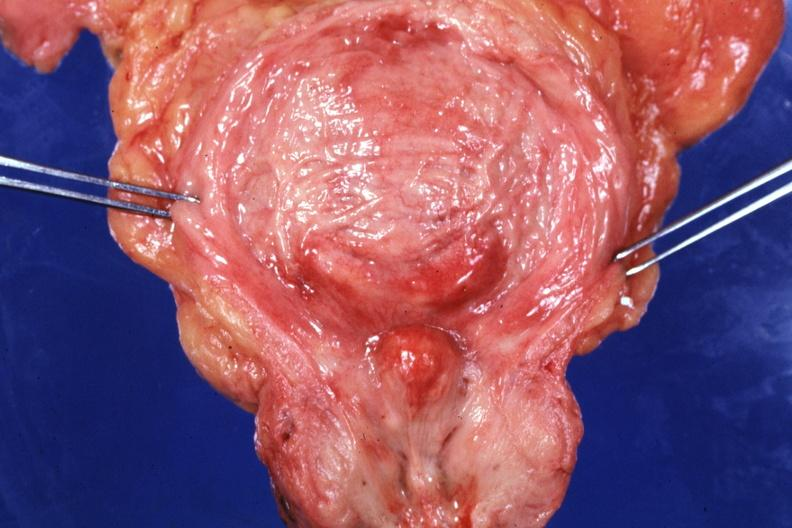s opened bladder with median lobe protruding into trigone area also had increase bladder trabeculations very good slide?
Answer the question using a single word or phrase. Yes 